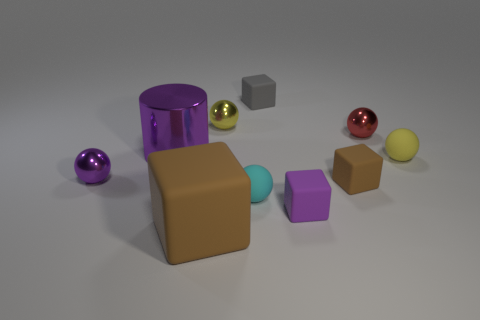Subtract all red balls. How many balls are left? 4 Subtract all small red shiny spheres. How many spheres are left? 4 Subtract 1 cubes. How many cubes are left? 3 Subtract all blue spheres. Subtract all purple cylinders. How many spheres are left? 5 Subtract all cylinders. How many objects are left? 9 Subtract 0 green blocks. How many objects are left? 10 Subtract all small red shiny spheres. Subtract all small metallic balls. How many objects are left? 6 Add 9 metallic cylinders. How many metallic cylinders are left? 10 Add 5 small red metallic cubes. How many small red metallic cubes exist? 5 